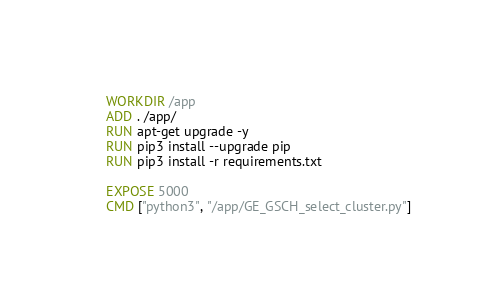<code> <loc_0><loc_0><loc_500><loc_500><_Dockerfile_>WORKDIR /app
ADD . /app/
RUN apt-get upgrade -y 
RUN pip3 install --upgrade pip
RUN pip3 install -r requirements.txt

EXPOSE 5000
CMD ["python3", "/app/GE_GSCH_select_cluster.py"]</code> 